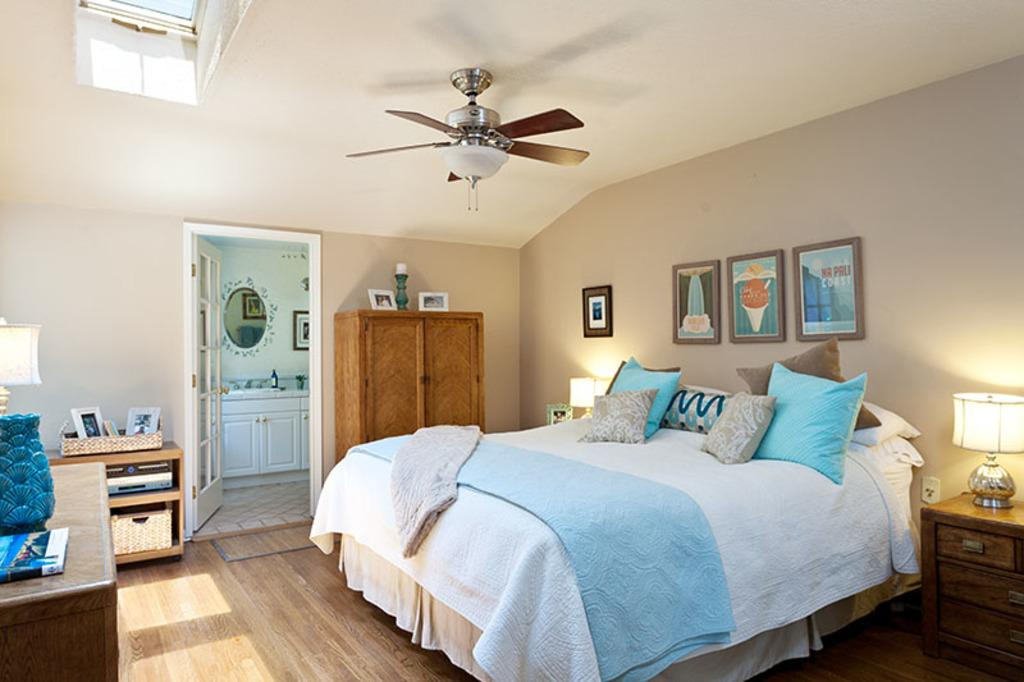What type of furniture is present in the image? There is a bed in the image. What is placed on the bed? There are pillows on the bed. What can be seen on the wall in the image? There are photo frames on the wall. What type of storage furniture is visible in the image? There is a cupboard in the image. What is used for air circulation in the image? There is a ceiling fan in the image. What type of feather is used to decorate the bed in the image? There is no feather used to decorate the bed in the image. What type of yoke is present in the image? There is no yoke present in the image. 